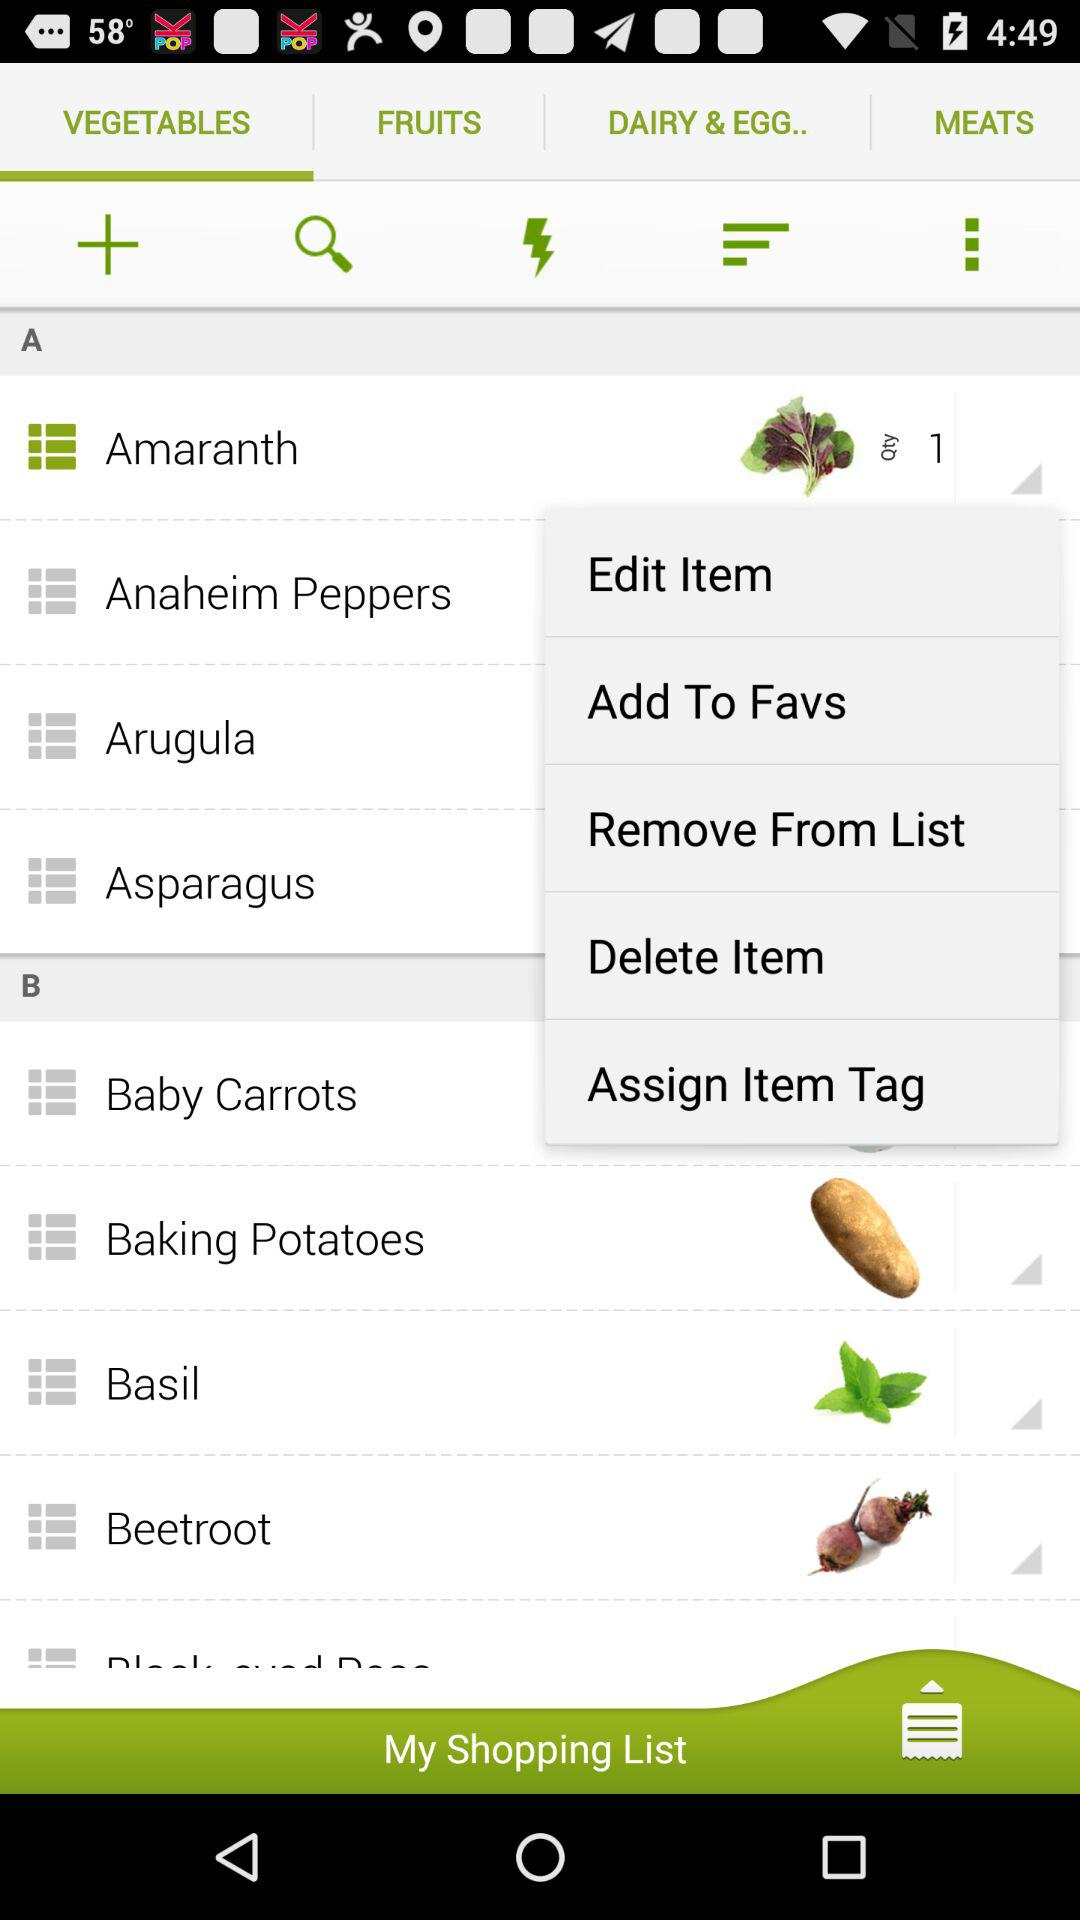Which tab is selected? The selected tab is "VEGETABLES". 